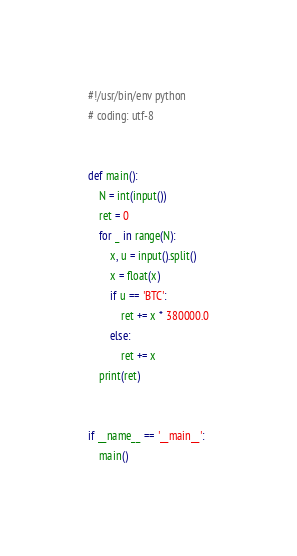<code> <loc_0><loc_0><loc_500><loc_500><_Python_>#!/usr/bin/env python
# coding: utf-8


def main():
    N = int(input())
    ret = 0
    for _ in range(N):
        x, u = input().split()
        x = float(x)
        if u == 'BTC':
            ret += x * 380000.0
        else:
            ret += x
    print(ret)


if __name__ == '__main__':
    main()
</code> 